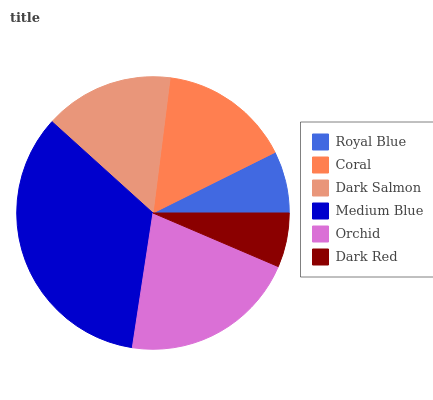Is Dark Red the minimum?
Answer yes or no. Yes. Is Medium Blue the maximum?
Answer yes or no. Yes. Is Coral the minimum?
Answer yes or no. No. Is Coral the maximum?
Answer yes or no. No. Is Coral greater than Royal Blue?
Answer yes or no. Yes. Is Royal Blue less than Coral?
Answer yes or no. Yes. Is Royal Blue greater than Coral?
Answer yes or no. No. Is Coral less than Royal Blue?
Answer yes or no. No. Is Coral the high median?
Answer yes or no. Yes. Is Dark Salmon the low median?
Answer yes or no. Yes. Is Dark Red the high median?
Answer yes or no. No. Is Orchid the low median?
Answer yes or no. No. 